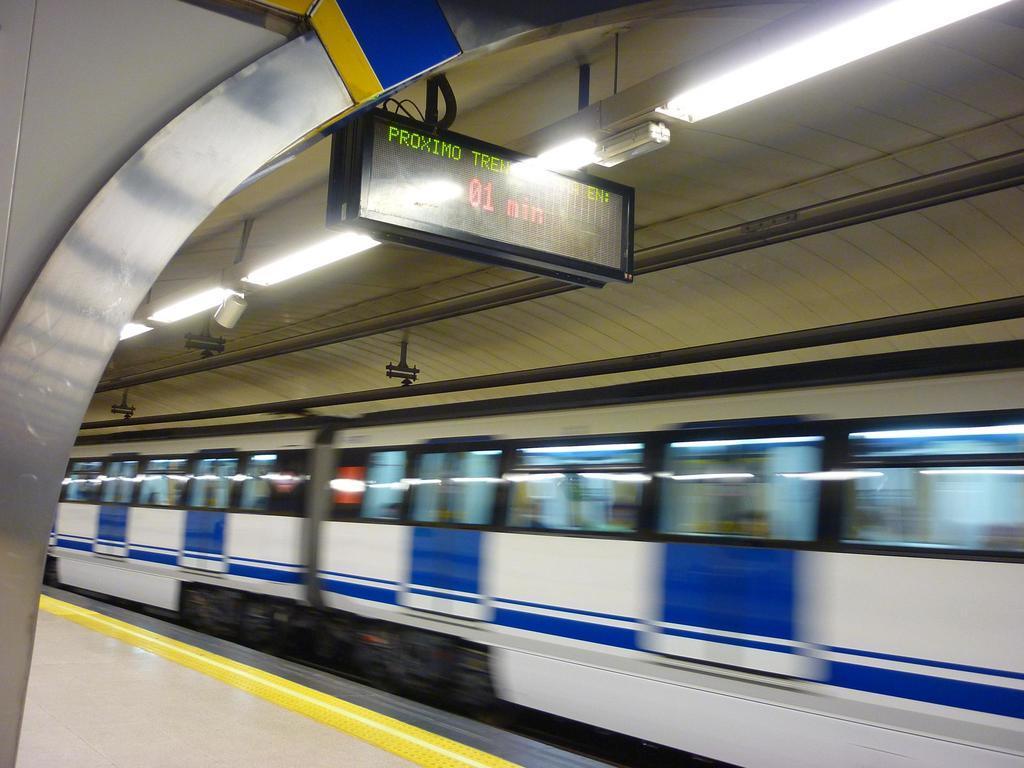Can you describe this image briefly? In the center of the image there is a train. At the top of the image there is a ceiling. There are lights. At the bottom of the image there is platform. 